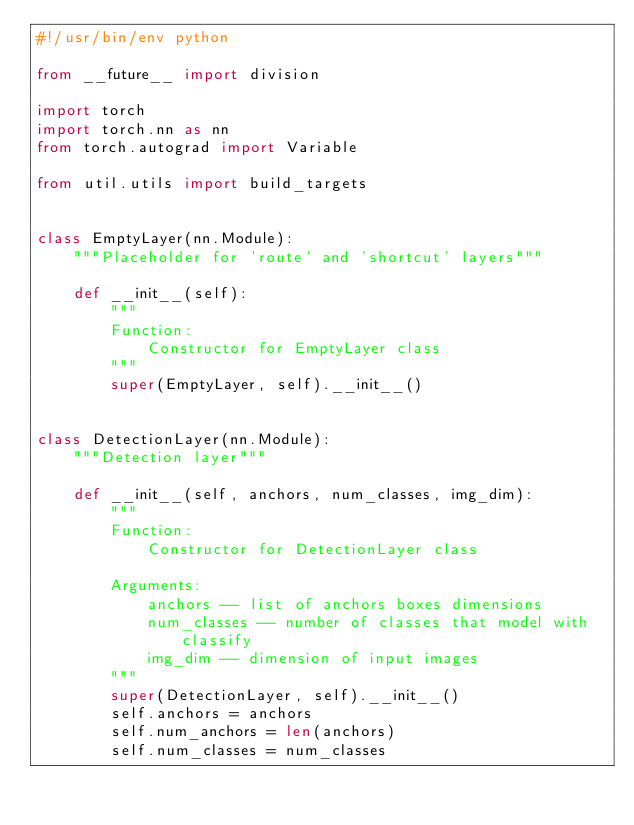Convert code to text. <code><loc_0><loc_0><loc_500><loc_500><_Python_>#!/usr/bin/env python

from __future__ import division

import torch 
import torch.nn as nn
from torch.autograd import Variable

from util.utils import build_targets


class EmptyLayer(nn.Module):
    """Placeholder for 'route' and 'shortcut' layers"""

    def __init__(self):            
        """
        Function:
            Constructor for EmptyLayer class
        """
        super(EmptyLayer, self).__init__()


class DetectionLayer(nn.Module):
    """Detection layer"""

    def __init__(self, anchors, num_classes, img_dim):
        """
        Function:
            Constructor for DetectionLayer class
            
        Arguments:
            anchors -- list of anchors boxes dimensions 
            num_classes -- number of classes that model with classify
            img_dim -- dimension of input images
        """
        super(DetectionLayer, self).__init__()
        self.anchors = anchors
        self.num_anchors = len(anchors)
        self.num_classes = num_classes</code> 